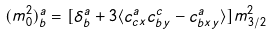Convert formula to latex. <formula><loc_0><loc_0><loc_500><loc_500>( m _ { 0 } ^ { 2 } ) _ { b } ^ { a } = [ \delta _ { b } ^ { a } + 3 \langle c _ { c x } ^ { a } c _ { b y } ^ { c } - c _ { b x y } ^ { a } \rangle ] m _ { 3 / 2 } ^ { 2 }</formula> 